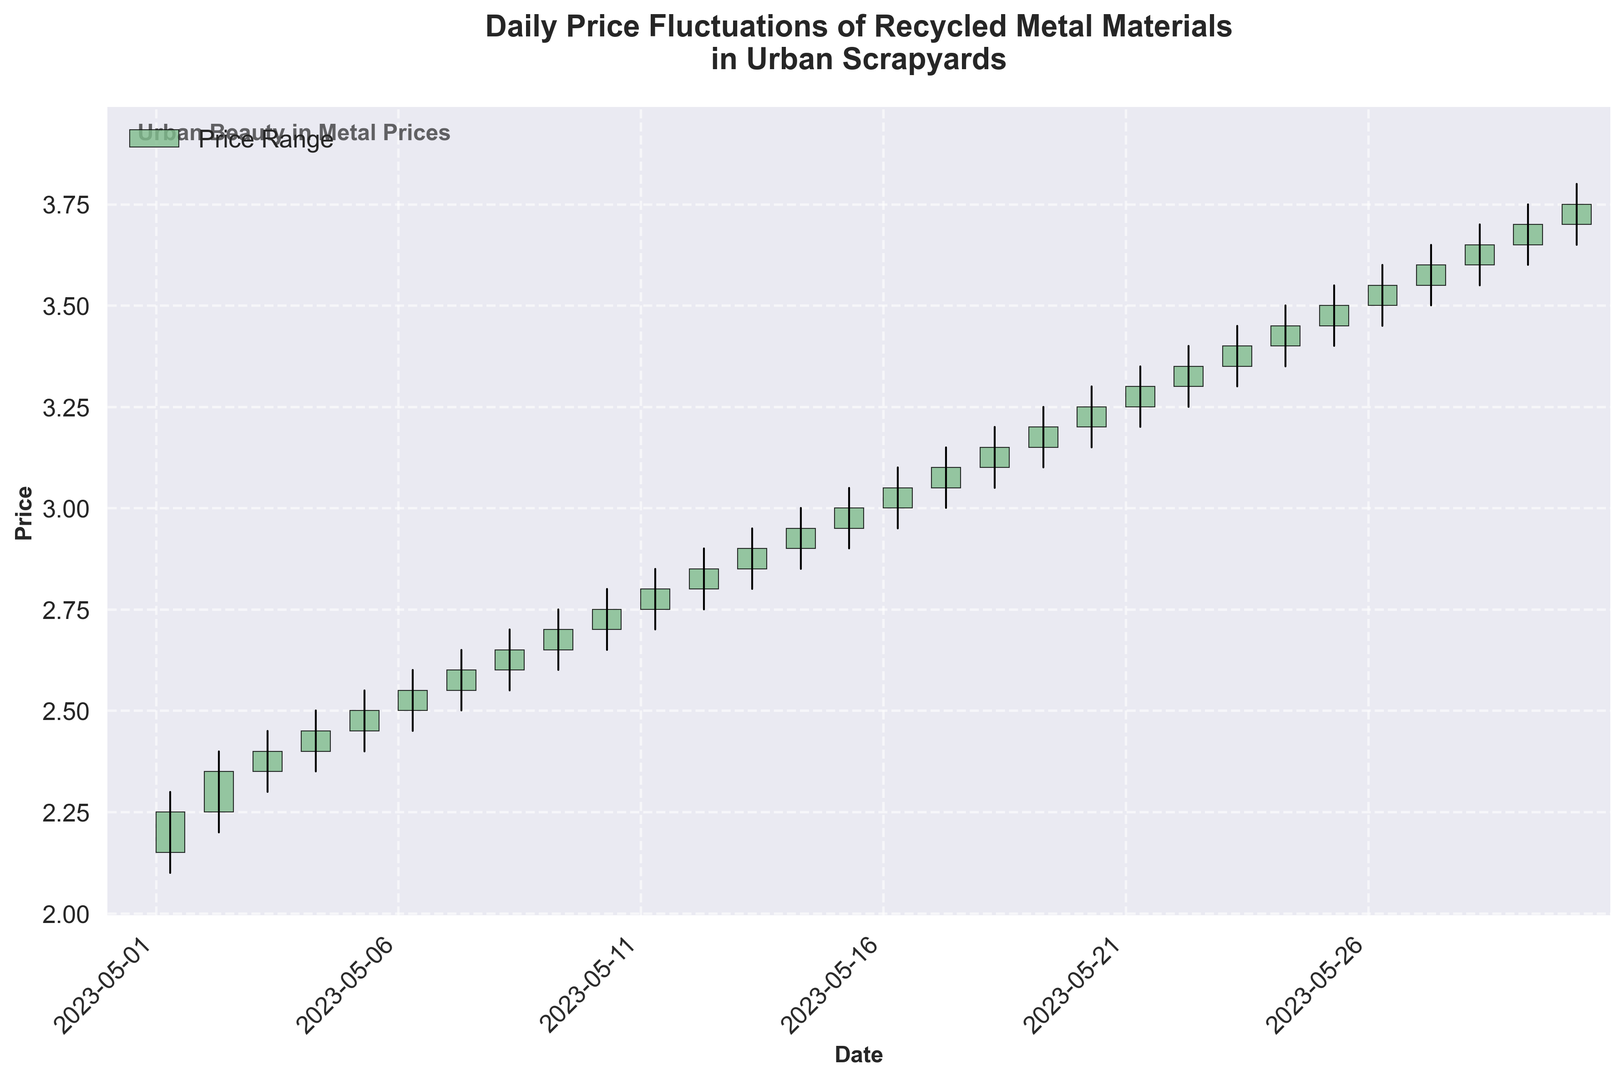What's the highest price recorded on any single day? The highest price is shown by the top limit of the tallest vertical line. Look for the highest point on the chart, which reaches up to 3.80.
Answer: 3.80 On which date did the price first reach the 3.00 mark? Check the figure and identify where the closing price first hits the 3.00 level, which corresponds to the 15th of May.
Answer: 2023-05-15 Was there ever a day where the closing price was lower than the opening price? Examine the color of the candlesticks. A red candlestick indicates the closing price is lower than the opening price. There are no red-colored candlesticks on the chart.
Answer: No Between which dates did the price increase the most? Identify the largest difference between opening and closing prices by comparing the heights of the green candlesticks. The period between 1st of May and 30th of May shows a consistent increase.
Answer: 2023-05-01 to 2023-05-30 Which day had the greatest range between the high and low prices? Examine the lengths of the vertical lines. The day with the longest vertical line corresponds to the 30th of May, ranging from 3.65 to 3.80.
Answer: 2023-05-30 What is the overall trend observed in the prices throughout May? Look at the position and slope of the candlesticks over time. They generally trend upwards from the beginning to the end of May.
Answer: Upward trend Which day had the smallest price range between the high and low prices? Identify the vertical line with the shortest length. The day with the smallest range is the 3rd of May, with high (2.45) and low (2.30) prices.
Answer: 2023-05-03 What is the average closing price for the period shown? Sum up all the closing prices and divide by the number of days. Calculation: (sum of all closing prices) / 30.
Answer: 2.925 Were there more days where the closing price was equal to or greater than the opening price, or fewer? Count the green candlesticks which represent days where the closing price was equal to or greater than the opening price (indicating more days where price went up or stayed the same). There are more green candlesticks than red.
Answer: More days 